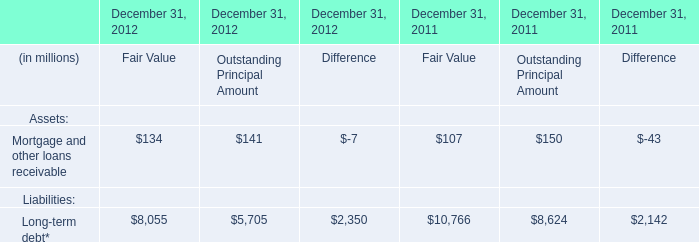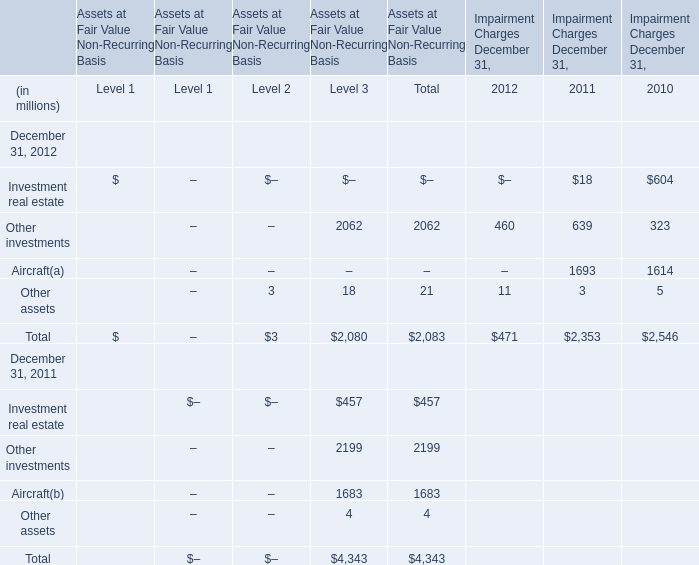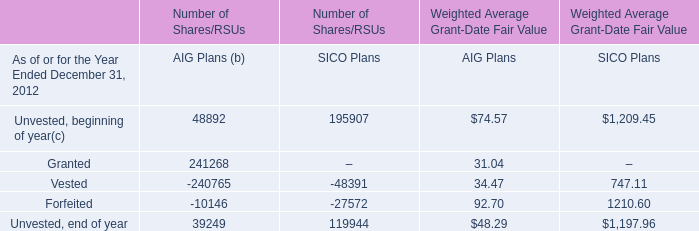What is the growing rate of Other assets in table 1 in the year with the most Other investments in table 1? 
Computations: ((21 - 4) / 4)
Answer: 4.25. 